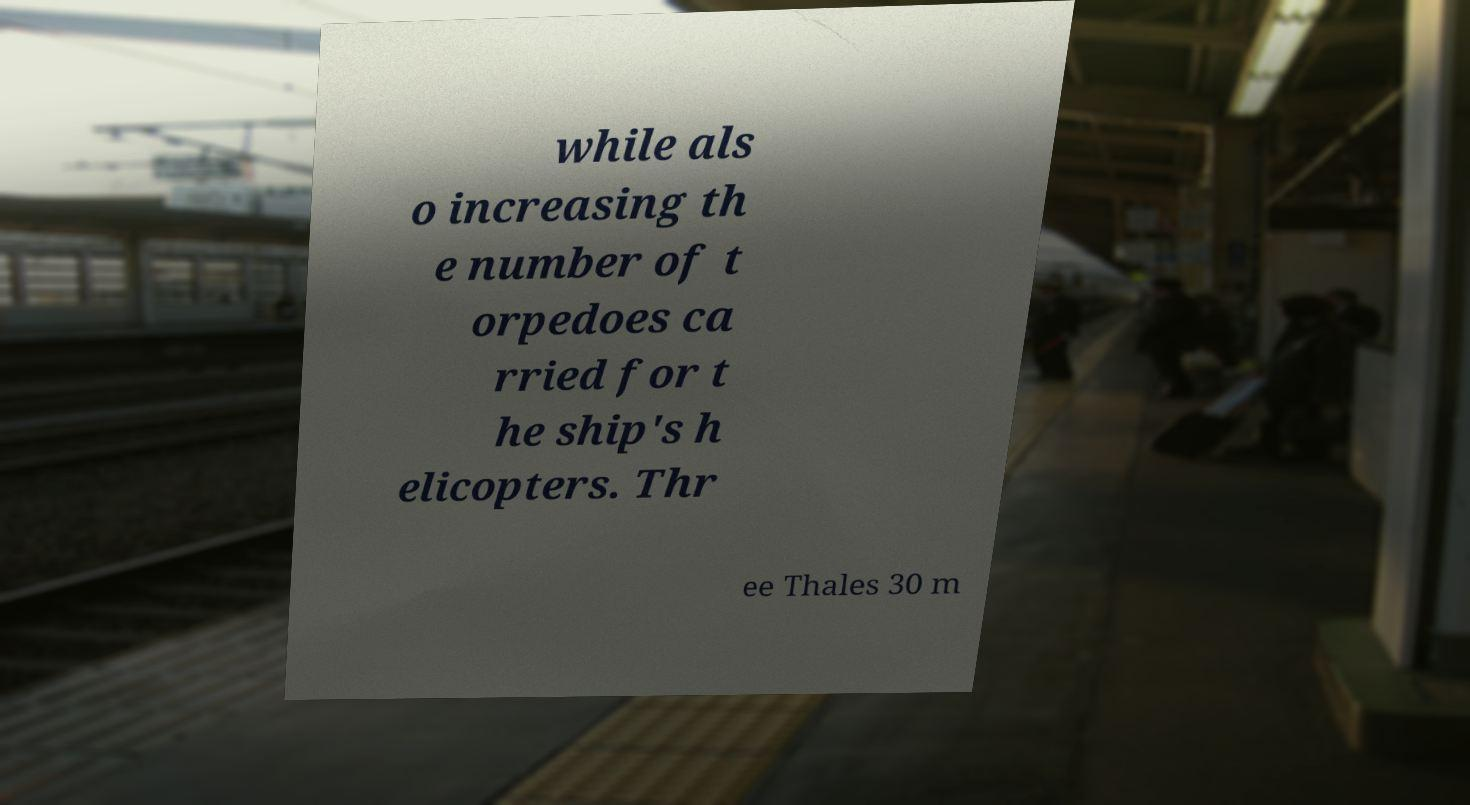There's text embedded in this image that I need extracted. Can you transcribe it verbatim? while als o increasing th e number of t orpedoes ca rried for t he ship's h elicopters. Thr ee Thales 30 m 